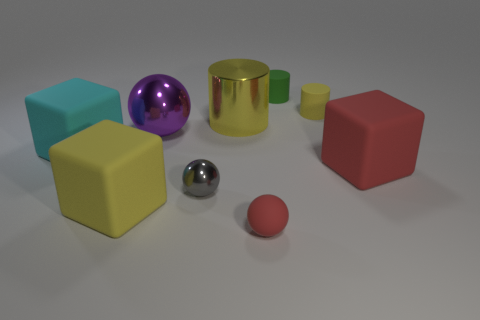How many matte things are small objects or large cyan things?
Ensure brevity in your answer.  4. What is the shape of the matte object that is the same color as the tiny rubber ball?
Give a very brief answer. Cube. There is a small cylinder that is left of the yellow matte cylinder; what material is it?
Give a very brief answer. Rubber. How many things are either gray objects or metal objects that are right of the big purple metallic thing?
Offer a terse response. 2. What shape is the gray metallic object that is the same size as the red matte ball?
Make the answer very short. Sphere. What number of tiny cylinders are the same color as the small shiny object?
Ensure brevity in your answer.  0. Is the small object on the left side of the tiny red rubber ball made of the same material as the cyan block?
Offer a terse response. No. What shape is the big cyan matte thing?
Provide a short and direct response. Cube. What number of red things are rubber blocks or large metallic cylinders?
Your answer should be very brief. 1. How many other things are there of the same material as the cyan block?
Keep it short and to the point. 5. 